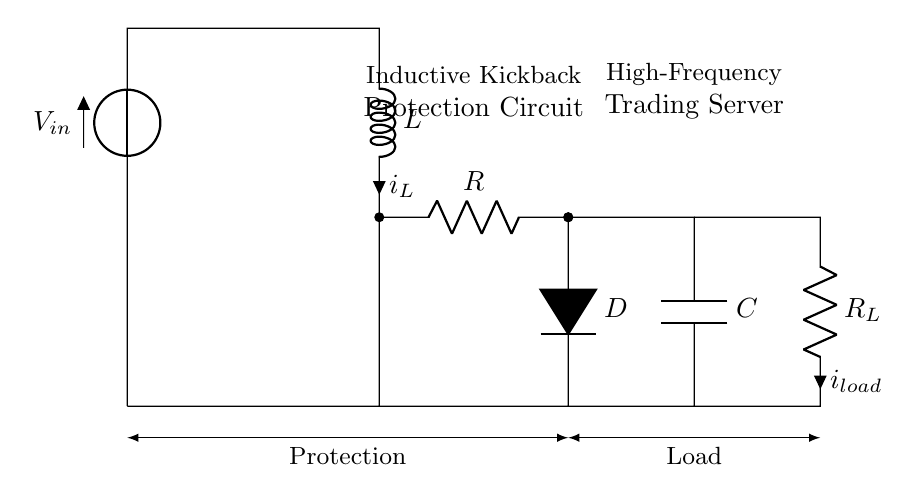What is the input voltage in this circuit? The input voltage is indicated as V_in at the top of the circuit. It represents the source voltage feeding the circuit.
Answer: V_in What is the role of the inductor in this circuit? The inductor L stores energy in its magnetic field and is critical for mitigating voltage spikes, also known as inductive kickback, that can occur when the current is suddenly interrupted.
Answer: Energy storage What type of diode is used in this circuit? The circuit shows a diode labeled D, which is typically a rectifier diode used for allowing current to pass in one direction while blocking it in the opposite direction, aiding in kickback protection.
Answer: Rectifier Where is the load resistor located? The load resistor R_L is positioned on the right side of the circuit diagram, clearly marked with its value and the current flowing through it.
Answer: Right side What happens during inductive kickback when the circuit is switched off? Upon switching off, the current through the inductor generates a high reverse voltage, which can damage components; the diode D allows this current to circulate, protecting the circuit.
Answer: Reverse voltage spike How does the capacitor contribute to this circuit? The capacitor C smooths the voltage levels and absorbs any high frequency disturbances or noise, helping maintain stable operation in a high-frequency trading environment.
Answer: Voltage smoothing 